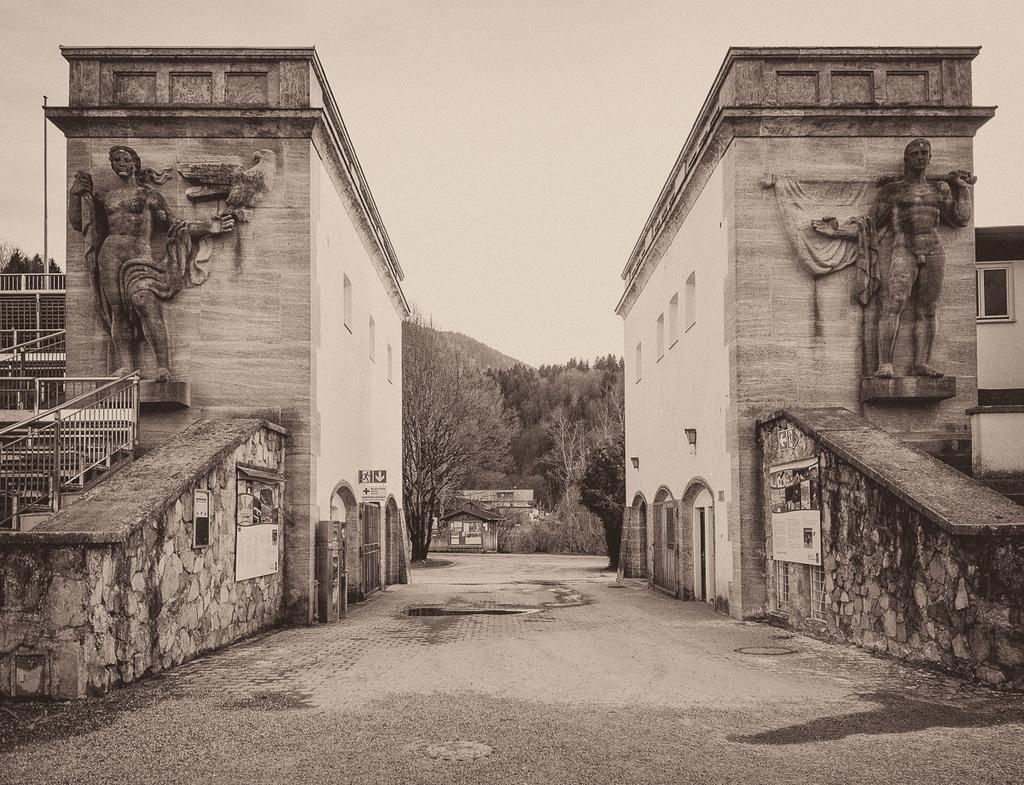Please provide a concise description of this image. In this image I can see the black and white picture in which I can see the road, two buildings on both sides of the road, two statues of persons standing, the railing, few windows of the building and in the background I can see few trees, few buildings and the sky. 